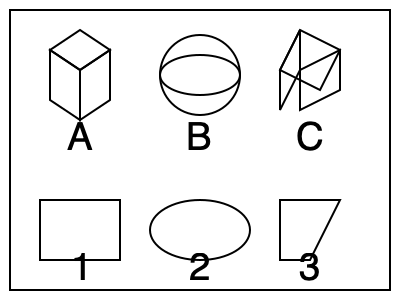Match the 3D objects (A, B, C) with their corresponding shadow projections (1, 2, 3). Which combination is correct? To match the 3D objects with their shadow projections, we need to analyze each object and its potential shadow:

1. Object A is a cube:
   - Its shadow would be a square or rectangle, depending on the angle of light.
   - This matches with shadow 1, which is a rectangle.

2. Object B is a sphere:
   - Its shadow would always be a circle, regardless of the angle of light.
   - This matches with shadow 2, which is an ellipse (a circle viewed from an angle).

3. Object C is a triangular prism:
   - Its shadow would be a quadrilateral shape, specifically a trapezoid or parallelogram, depending on the angle of light.
   - This matches with shadow 3, which is a trapezoid.

Therefore, the correct matching is:
A → 1
B → 2
C → 3
Answer: A-1, B-2, C-3 